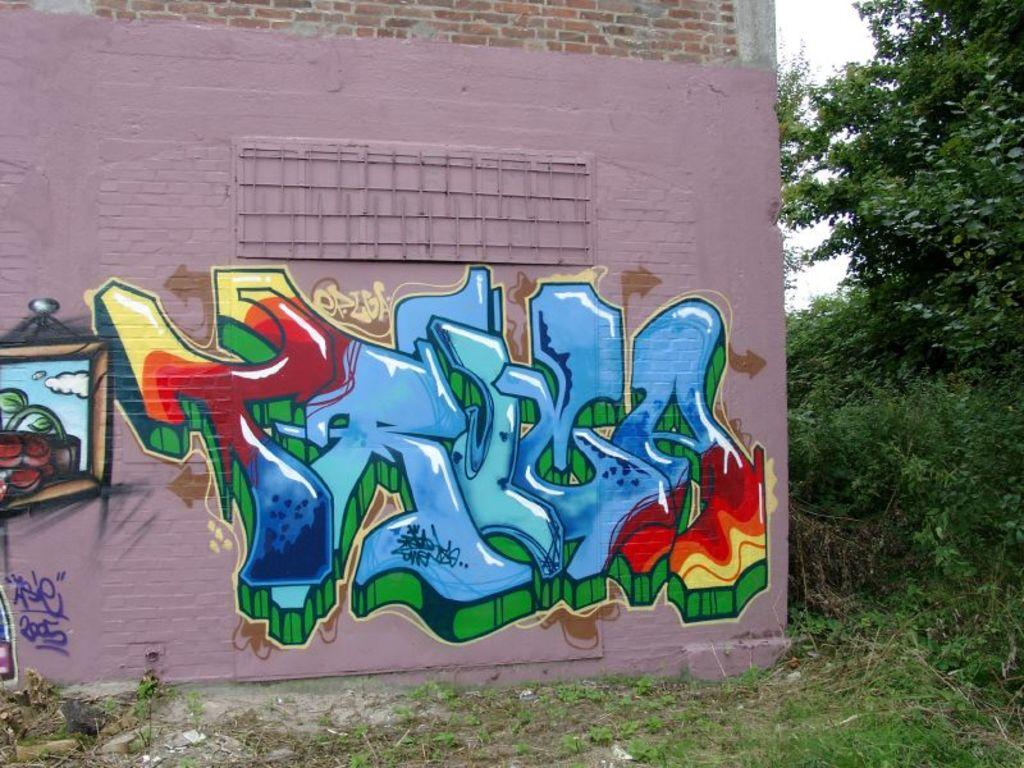What is present on the wall in the image? There is a painting on the wall in the image. What is the color of the grass on the ground? The grass on the ground is green. What other natural elements can be seen in the image? There are trees in the image. How much was the payment for the painting in the image? There is no information about payment in the image, as it only shows a painting on the wall. What type of cord is connected to the painting in the image? There is no cord connected to the painting in the image; it is simply hanging on the wall. 